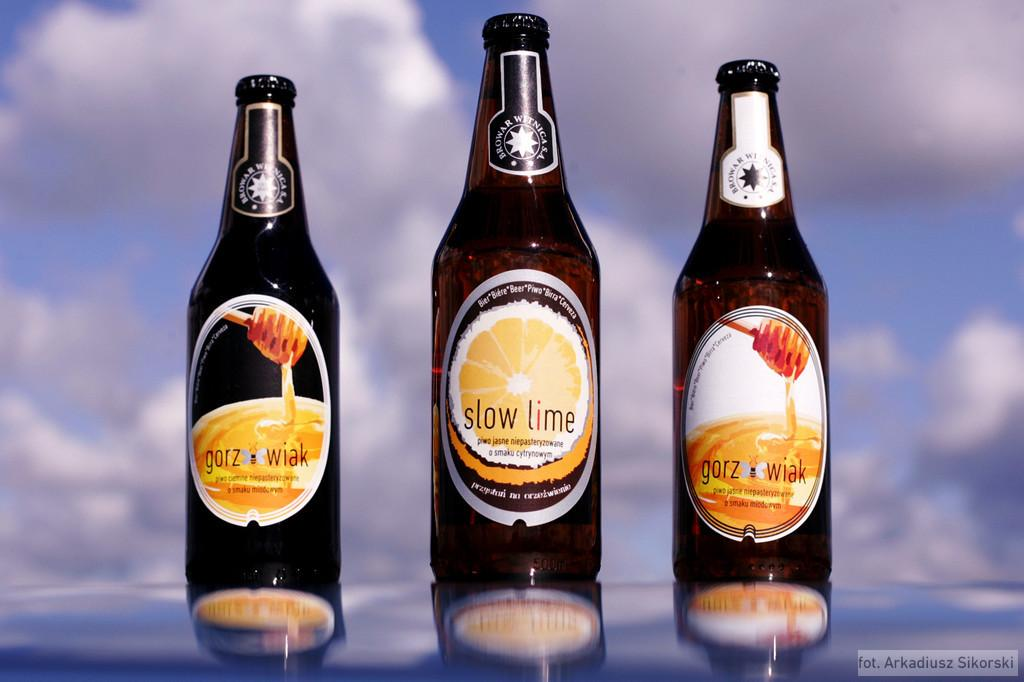Provide a one-sentence caption for the provided image. Slow lime beer bottle between two Gorz Wiak beer bottles. 